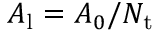<formula> <loc_0><loc_0><loc_500><loc_500>A _ { l } = A _ { 0 } / N _ { t }</formula> 